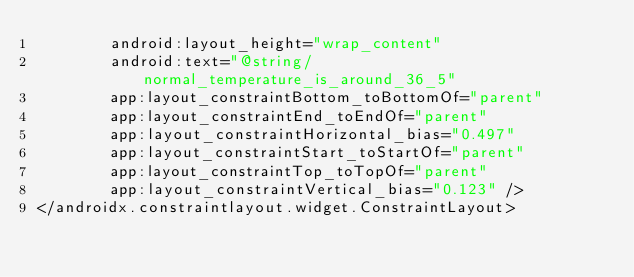Convert code to text. <code><loc_0><loc_0><loc_500><loc_500><_XML_>        android:layout_height="wrap_content"
        android:text="@string/normal_temperature_is_around_36_5"
        app:layout_constraintBottom_toBottomOf="parent"
        app:layout_constraintEnd_toEndOf="parent"
        app:layout_constraintHorizontal_bias="0.497"
        app:layout_constraintStart_toStartOf="parent"
        app:layout_constraintTop_toTopOf="parent"
        app:layout_constraintVertical_bias="0.123" />
</androidx.constraintlayout.widget.ConstraintLayout></code> 